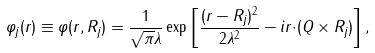<formula> <loc_0><loc_0><loc_500><loc_500>\varphi _ { j } ( { r } ) \equiv \varphi ( { r } , { R } _ { j } ) = \frac { 1 } { \sqrt { \pi } \lambda } \exp \left [ \frac { ( { r } - { R } _ { j } ) ^ { 2 } } { 2 \lambda ^ { 2 } } - i { r } { \cdot } ( { Q } \times { R } _ { j } ) \right ] ,</formula> 